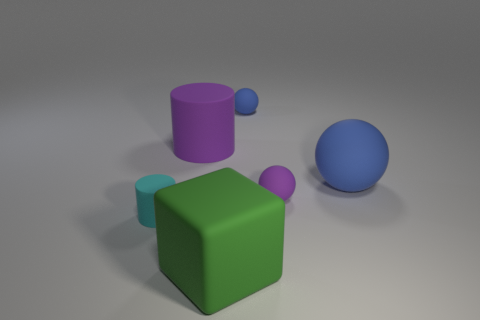Are there any tiny blocks?
Make the answer very short. No. How many other objects are the same material as the tiny purple object?
Provide a succinct answer. 5. There is a cylinder that is the same size as the block; what material is it?
Keep it short and to the point. Rubber. There is a purple object that is right of the small blue object; is it the same shape as the big blue thing?
Provide a succinct answer. Yes. What number of things are rubber objects on the right side of the tiny blue ball or big cubes?
Make the answer very short. 3. What is the shape of the blue thing that is the same size as the matte block?
Ensure brevity in your answer.  Sphere. There is a purple rubber thing to the left of the green object; does it have the same size as the purple matte object that is in front of the big rubber cylinder?
Give a very brief answer. No. What is the color of the large sphere that is made of the same material as the tiny blue ball?
Your answer should be compact. Blue. Is there a green thing of the same size as the purple rubber cylinder?
Your answer should be very brief. Yes. What size is the purple matte object that is on the right side of the large object in front of the tiny matte cylinder?
Provide a succinct answer. Small. 